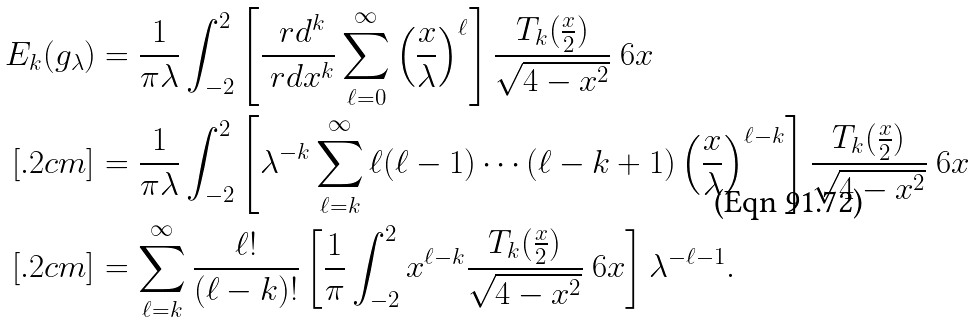Convert formula to latex. <formula><loc_0><loc_0><loc_500><loc_500>E _ { k } ( g _ { \lambda } ) & = \frac { 1 } { \pi \lambda } \int _ { - 2 } ^ { 2 } \left [ \frac { \ r d ^ { k } } { \ r d x ^ { k } } \sum _ { \ell = 0 } ^ { \infty } \left ( \frac { x } { \lambda } \right ) ^ { \ell } \right ] \frac { T _ { k } ( \frac { x } { 2 } ) } { \sqrt { 4 - x ^ { 2 } } } \ 6 x \\ [ . 2 c m ] & = \frac { 1 } { \pi \lambda } \int _ { - 2 } ^ { 2 } \left [ \lambda ^ { - k } \sum _ { \ell = k } ^ { \infty } \ell ( \ell - 1 ) \cdots ( \ell - k + 1 ) \left ( \frac { x } { \lambda } \right ) ^ { \ell - k } \right ] \frac { T _ { k } ( \frac { x } { 2 } ) } { \sqrt { 4 - x ^ { 2 } } } \ 6 x \\ [ . 2 c m ] & = \sum _ { \ell = k } ^ { \infty } \frac { \ell ! } { ( \ell - k ) ! } \left [ \frac { 1 } { \pi } \int _ { - 2 } ^ { 2 } x ^ { \ell - k } \frac { T _ { k } ( \frac { x } { 2 } ) } { \sqrt { 4 - x ^ { 2 } } } \ 6 x \right ] \lambda ^ { - \ell - 1 } .</formula> 